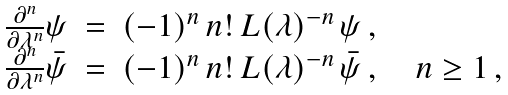Convert formula to latex. <formula><loc_0><loc_0><loc_500><loc_500>\begin{array} { r c l } { { \frac { \partial ^ { n } } { \partial \lambda ^ { n } } \psi } } & { = } & { { ( - 1 ) ^ { n } \, n ! \, L ( \lambda ) ^ { - n } \, \psi \, , } } \\ { { \frac { \partial ^ { n } } { \partial \lambda ^ { n } } \bar { \psi } } } & { = } & { { ( - 1 ) ^ { n } \, n ! \, L ( \lambda ) ^ { - n } \, \bar { \psi } \, , \quad n \geq 1 \, , } } \end{array}</formula> 